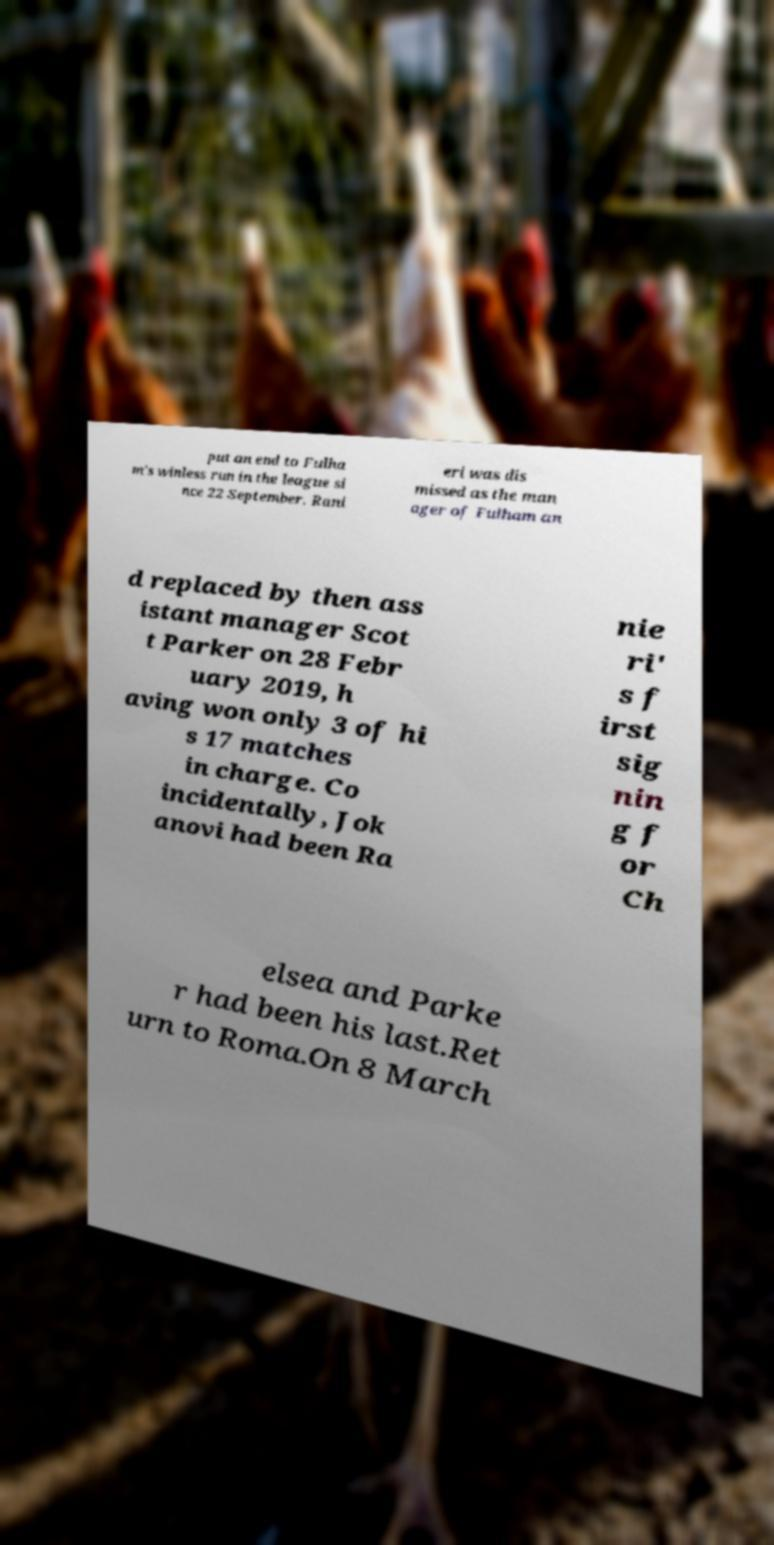Can you accurately transcribe the text from the provided image for me? put an end to Fulha m's winless run in the league si nce 22 September. Rani eri was dis missed as the man ager of Fulham an d replaced by then ass istant manager Scot t Parker on 28 Febr uary 2019, h aving won only 3 of hi s 17 matches in charge. Co incidentally, Jok anovi had been Ra nie ri' s f irst sig nin g f or Ch elsea and Parke r had been his last.Ret urn to Roma.On 8 March 